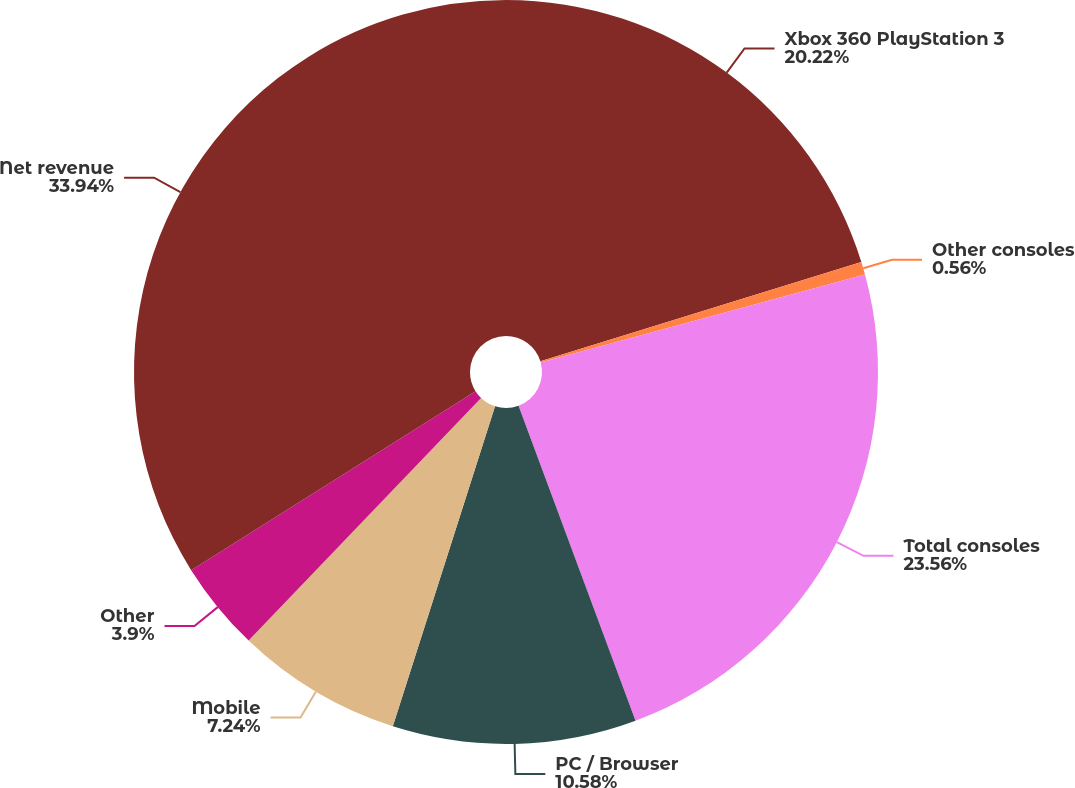Convert chart. <chart><loc_0><loc_0><loc_500><loc_500><pie_chart><fcel>Xbox 360 PlayStation 3<fcel>Other consoles<fcel>Total consoles<fcel>PC / Browser<fcel>Mobile<fcel>Other<fcel>Net revenue<nl><fcel>20.22%<fcel>0.56%<fcel>23.56%<fcel>10.58%<fcel>7.24%<fcel>3.9%<fcel>33.94%<nl></chart> 